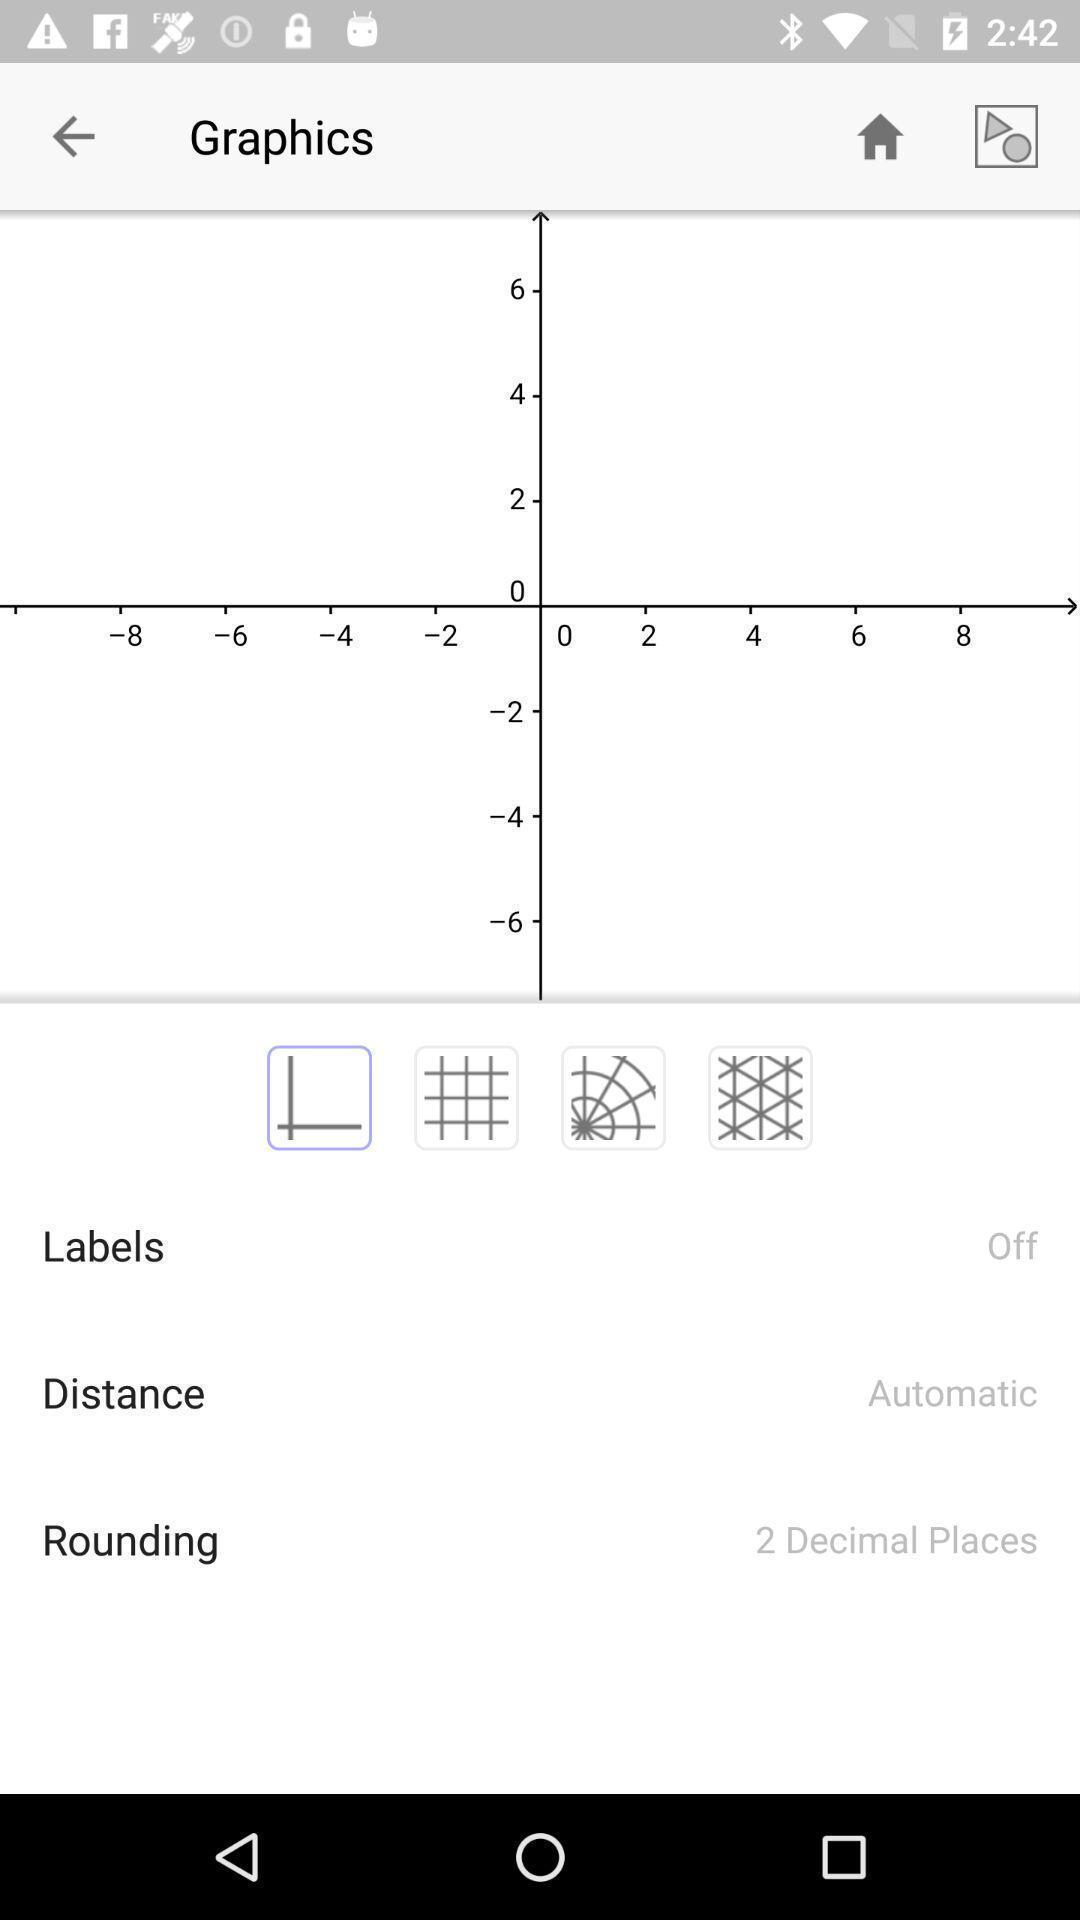Give me a summary of this screen capture. Screen displaying the graphics page. 